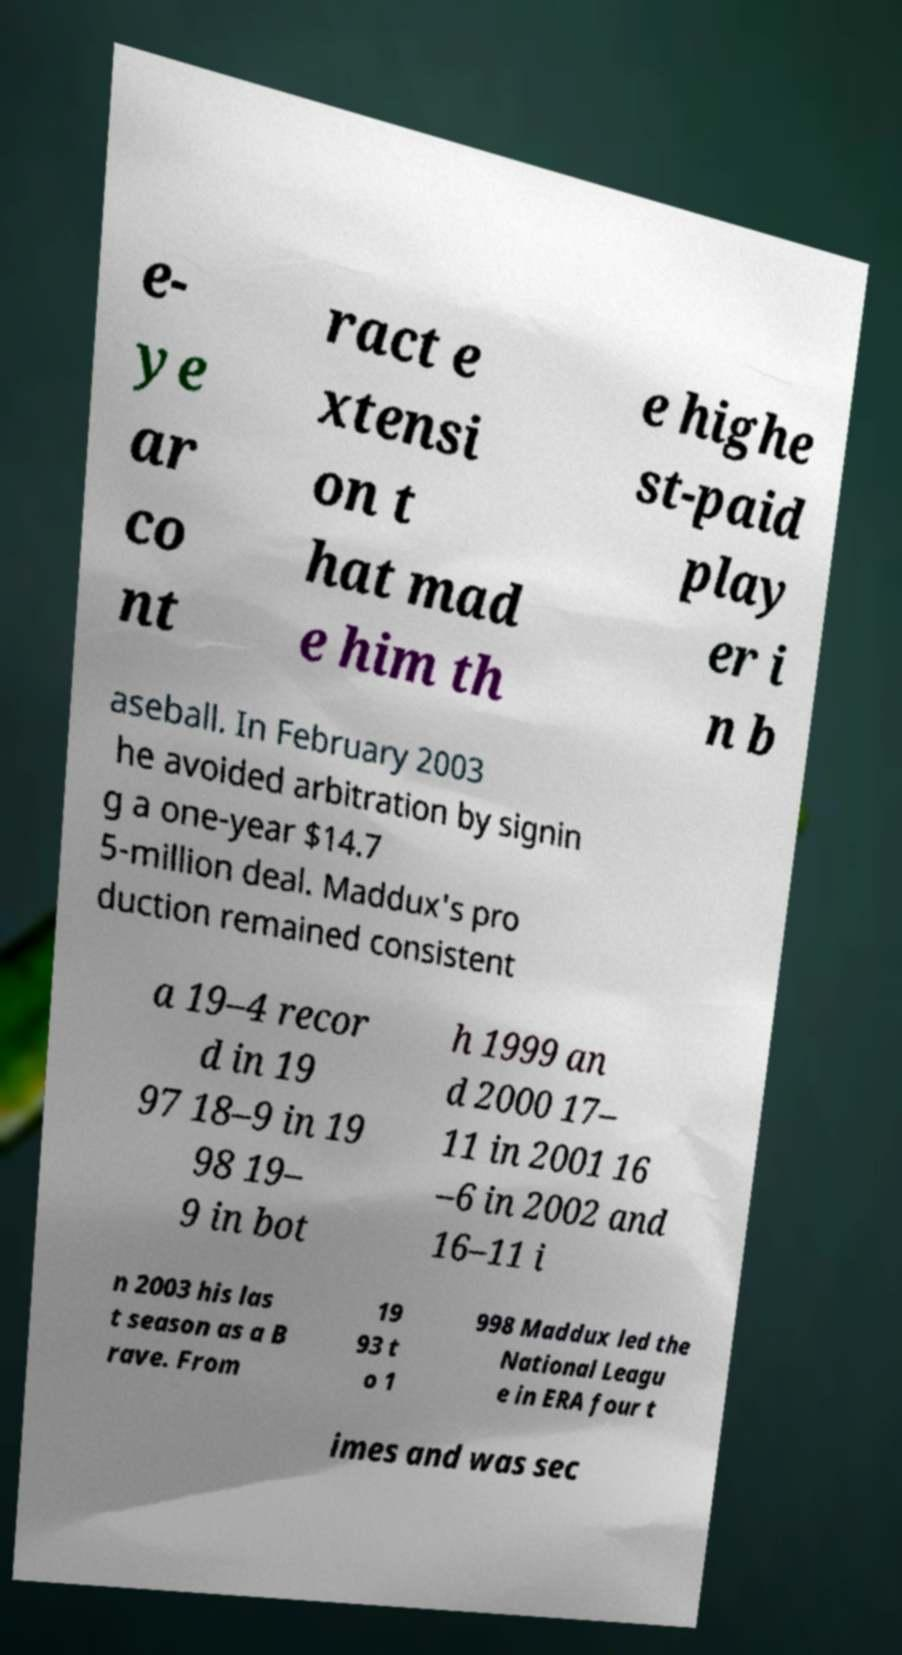Could you assist in decoding the text presented in this image and type it out clearly? e- ye ar co nt ract e xtensi on t hat mad e him th e highe st-paid play er i n b aseball. In February 2003 he avoided arbitration by signin g a one-year $14.7 5-million deal. Maddux's pro duction remained consistent a 19–4 recor d in 19 97 18–9 in 19 98 19– 9 in bot h 1999 an d 2000 17– 11 in 2001 16 –6 in 2002 and 16–11 i n 2003 his las t season as a B rave. From 19 93 t o 1 998 Maddux led the National Leagu e in ERA four t imes and was sec 